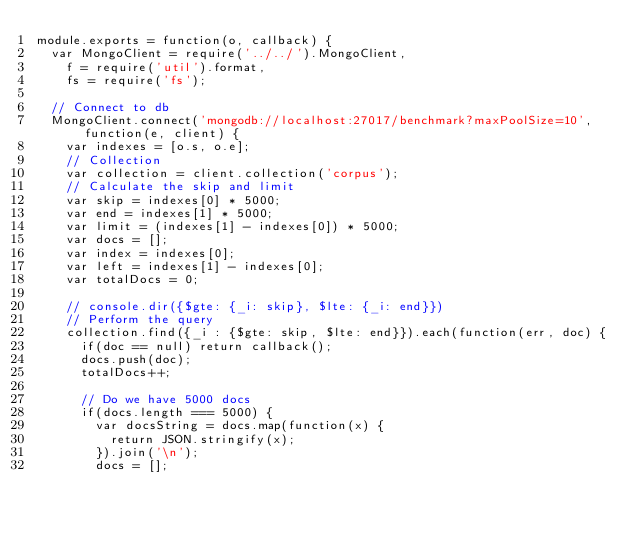<code> <loc_0><loc_0><loc_500><loc_500><_JavaScript_>module.exports = function(o, callback) {
  var MongoClient = require('../../').MongoClient,
    f = require('util').format,
    fs = require('fs');

  // Connect to db
  MongoClient.connect('mongodb://localhost:27017/benchmark?maxPoolSize=10', function(e, client) {
    var indexes = [o.s, o.e];
    // Collection
    var collection = client.collection('corpus');
    // Calculate the skip and limit
    var skip = indexes[0] * 5000;
    var end = indexes[1] * 5000;
    var limit = (indexes[1] - indexes[0]) * 5000;
    var docs = [];
    var index = indexes[0];
    var left = indexes[1] - indexes[0];
    var totalDocs = 0;

    // console.dir({$gte: {_i: skip}, $lte: {_i: end}})
    // Perform the query
    collection.find({_i : {$gte: skip, $lte: end}}).each(function(err, doc) {
      if(doc == null) return callback();
      docs.push(doc);
      totalDocs++;

      // Do we have 5000 docs
      if(docs.length === 5000) {
        var docsString = docs.map(function(x) {
          return JSON.stringify(x);
        }).join('\n');
        docs = [];
</code> 